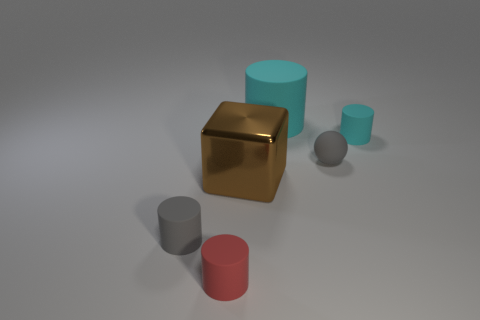Subtract all large cyan cylinders. How many cylinders are left? 3 Add 1 yellow rubber cylinders. How many objects exist? 7 Subtract 1 cylinders. How many cylinders are left? 3 Subtract all green balls. Subtract all purple blocks. How many balls are left? 1 Subtract all red balls. How many cyan cylinders are left? 2 Subtract all cyan objects. Subtract all big cubes. How many objects are left? 3 Add 2 gray rubber cylinders. How many gray rubber cylinders are left? 3 Add 5 tiny brown cylinders. How many tiny brown cylinders exist? 5 Subtract all red cylinders. How many cylinders are left? 3 Subtract 0 brown balls. How many objects are left? 6 